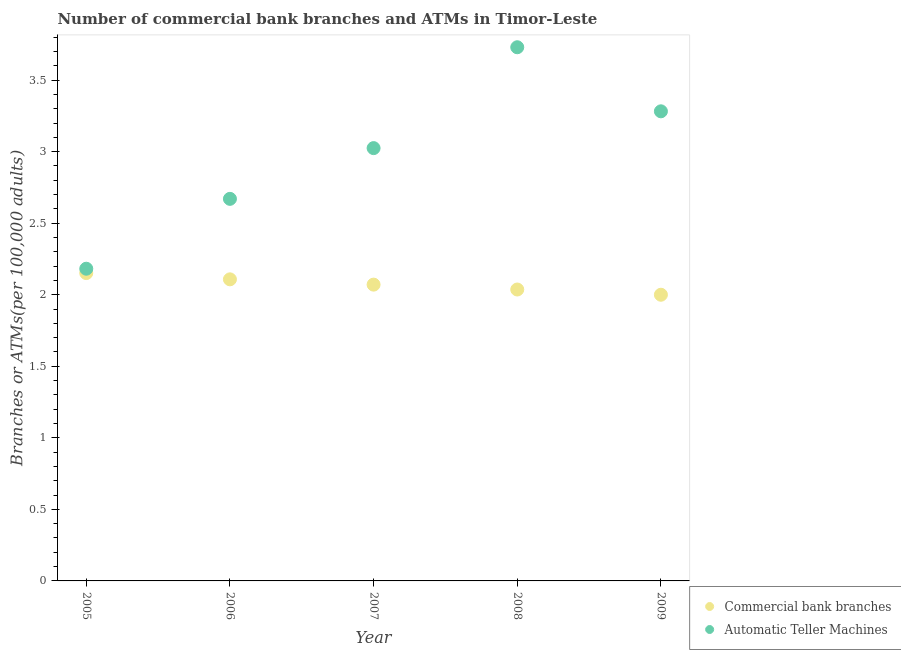How many different coloured dotlines are there?
Provide a succinct answer. 2. What is the number of commercal bank branches in 2005?
Provide a short and direct response. 2.15. Across all years, what is the maximum number of atms?
Your response must be concise. 3.73. Across all years, what is the minimum number of atms?
Keep it short and to the point. 2.18. In which year was the number of atms maximum?
Provide a succinct answer. 2008. What is the total number of atms in the graph?
Keep it short and to the point. 14.89. What is the difference between the number of commercal bank branches in 2007 and that in 2008?
Ensure brevity in your answer.  0.03. What is the difference between the number of commercal bank branches in 2007 and the number of atms in 2009?
Your answer should be compact. -1.21. What is the average number of commercal bank branches per year?
Provide a short and direct response. 2.07. In the year 2006, what is the difference between the number of atms and number of commercal bank branches?
Ensure brevity in your answer.  0.56. In how many years, is the number of atms greater than 0.6?
Offer a terse response. 5. What is the ratio of the number of atms in 2005 to that in 2007?
Your answer should be very brief. 0.72. What is the difference between the highest and the second highest number of atms?
Your response must be concise. 0.45. What is the difference between the highest and the lowest number of atms?
Give a very brief answer. 1.55. In how many years, is the number of commercal bank branches greater than the average number of commercal bank branches taken over all years?
Ensure brevity in your answer.  2. Is the sum of the number of atms in 2006 and 2009 greater than the maximum number of commercal bank branches across all years?
Make the answer very short. Yes. Is the number of atms strictly less than the number of commercal bank branches over the years?
Provide a short and direct response. No. How many dotlines are there?
Provide a short and direct response. 2. What is the difference between two consecutive major ticks on the Y-axis?
Your answer should be compact. 0.5. Where does the legend appear in the graph?
Provide a succinct answer. Bottom right. How many legend labels are there?
Provide a succinct answer. 2. How are the legend labels stacked?
Provide a succinct answer. Vertical. What is the title of the graph?
Offer a very short reply. Number of commercial bank branches and ATMs in Timor-Leste. Does "% of gross capital formation" appear as one of the legend labels in the graph?
Give a very brief answer. No. What is the label or title of the Y-axis?
Ensure brevity in your answer.  Branches or ATMs(per 100,0 adults). What is the Branches or ATMs(per 100,000 adults) in Commercial bank branches in 2005?
Your answer should be very brief. 2.15. What is the Branches or ATMs(per 100,000 adults) of Automatic Teller Machines in 2005?
Ensure brevity in your answer.  2.18. What is the Branches or ATMs(per 100,000 adults) in Commercial bank branches in 2006?
Offer a very short reply. 2.11. What is the Branches or ATMs(per 100,000 adults) in Automatic Teller Machines in 2006?
Your answer should be compact. 2.67. What is the Branches or ATMs(per 100,000 adults) in Commercial bank branches in 2007?
Keep it short and to the point. 2.07. What is the Branches or ATMs(per 100,000 adults) in Automatic Teller Machines in 2007?
Your answer should be compact. 3.02. What is the Branches or ATMs(per 100,000 adults) of Commercial bank branches in 2008?
Provide a succinct answer. 2.04. What is the Branches or ATMs(per 100,000 adults) in Automatic Teller Machines in 2008?
Give a very brief answer. 3.73. What is the Branches or ATMs(per 100,000 adults) in Commercial bank branches in 2009?
Ensure brevity in your answer.  2. What is the Branches or ATMs(per 100,000 adults) in Automatic Teller Machines in 2009?
Your answer should be very brief. 3.28. Across all years, what is the maximum Branches or ATMs(per 100,000 adults) of Commercial bank branches?
Ensure brevity in your answer.  2.15. Across all years, what is the maximum Branches or ATMs(per 100,000 adults) of Automatic Teller Machines?
Ensure brevity in your answer.  3.73. Across all years, what is the minimum Branches or ATMs(per 100,000 adults) of Commercial bank branches?
Provide a short and direct response. 2. Across all years, what is the minimum Branches or ATMs(per 100,000 adults) in Automatic Teller Machines?
Your answer should be compact. 2.18. What is the total Branches or ATMs(per 100,000 adults) in Commercial bank branches in the graph?
Provide a succinct answer. 10.37. What is the total Branches or ATMs(per 100,000 adults) in Automatic Teller Machines in the graph?
Your answer should be very brief. 14.89. What is the difference between the Branches or ATMs(per 100,000 adults) of Commercial bank branches in 2005 and that in 2006?
Give a very brief answer. 0.04. What is the difference between the Branches or ATMs(per 100,000 adults) in Automatic Teller Machines in 2005 and that in 2006?
Give a very brief answer. -0.49. What is the difference between the Branches or ATMs(per 100,000 adults) in Commercial bank branches in 2005 and that in 2007?
Your answer should be very brief. 0.08. What is the difference between the Branches or ATMs(per 100,000 adults) in Automatic Teller Machines in 2005 and that in 2007?
Your answer should be compact. -0.84. What is the difference between the Branches or ATMs(per 100,000 adults) of Commercial bank branches in 2005 and that in 2008?
Offer a very short reply. 0.11. What is the difference between the Branches or ATMs(per 100,000 adults) of Automatic Teller Machines in 2005 and that in 2008?
Make the answer very short. -1.55. What is the difference between the Branches or ATMs(per 100,000 adults) of Commercial bank branches in 2005 and that in 2009?
Offer a terse response. 0.15. What is the difference between the Branches or ATMs(per 100,000 adults) in Automatic Teller Machines in 2005 and that in 2009?
Your answer should be very brief. -1.1. What is the difference between the Branches or ATMs(per 100,000 adults) in Commercial bank branches in 2006 and that in 2007?
Offer a very short reply. 0.04. What is the difference between the Branches or ATMs(per 100,000 adults) in Automatic Teller Machines in 2006 and that in 2007?
Your answer should be compact. -0.35. What is the difference between the Branches or ATMs(per 100,000 adults) of Commercial bank branches in 2006 and that in 2008?
Make the answer very short. 0.07. What is the difference between the Branches or ATMs(per 100,000 adults) in Automatic Teller Machines in 2006 and that in 2008?
Your answer should be very brief. -1.06. What is the difference between the Branches or ATMs(per 100,000 adults) of Commercial bank branches in 2006 and that in 2009?
Provide a short and direct response. 0.11. What is the difference between the Branches or ATMs(per 100,000 adults) in Automatic Teller Machines in 2006 and that in 2009?
Ensure brevity in your answer.  -0.61. What is the difference between the Branches or ATMs(per 100,000 adults) of Commercial bank branches in 2007 and that in 2008?
Your response must be concise. 0.03. What is the difference between the Branches or ATMs(per 100,000 adults) in Automatic Teller Machines in 2007 and that in 2008?
Ensure brevity in your answer.  -0.7. What is the difference between the Branches or ATMs(per 100,000 adults) in Commercial bank branches in 2007 and that in 2009?
Ensure brevity in your answer.  0.07. What is the difference between the Branches or ATMs(per 100,000 adults) in Automatic Teller Machines in 2007 and that in 2009?
Your answer should be very brief. -0.26. What is the difference between the Branches or ATMs(per 100,000 adults) in Commercial bank branches in 2008 and that in 2009?
Offer a terse response. 0.04. What is the difference between the Branches or ATMs(per 100,000 adults) of Automatic Teller Machines in 2008 and that in 2009?
Offer a terse response. 0.45. What is the difference between the Branches or ATMs(per 100,000 adults) of Commercial bank branches in 2005 and the Branches or ATMs(per 100,000 adults) of Automatic Teller Machines in 2006?
Your answer should be compact. -0.52. What is the difference between the Branches or ATMs(per 100,000 adults) in Commercial bank branches in 2005 and the Branches or ATMs(per 100,000 adults) in Automatic Teller Machines in 2007?
Offer a terse response. -0.87. What is the difference between the Branches or ATMs(per 100,000 adults) in Commercial bank branches in 2005 and the Branches or ATMs(per 100,000 adults) in Automatic Teller Machines in 2008?
Keep it short and to the point. -1.58. What is the difference between the Branches or ATMs(per 100,000 adults) of Commercial bank branches in 2005 and the Branches or ATMs(per 100,000 adults) of Automatic Teller Machines in 2009?
Make the answer very short. -1.13. What is the difference between the Branches or ATMs(per 100,000 adults) in Commercial bank branches in 2006 and the Branches or ATMs(per 100,000 adults) in Automatic Teller Machines in 2007?
Your answer should be very brief. -0.92. What is the difference between the Branches or ATMs(per 100,000 adults) in Commercial bank branches in 2006 and the Branches or ATMs(per 100,000 adults) in Automatic Teller Machines in 2008?
Keep it short and to the point. -1.62. What is the difference between the Branches or ATMs(per 100,000 adults) of Commercial bank branches in 2006 and the Branches or ATMs(per 100,000 adults) of Automatic Teller Machines in 2009?
Offer a very short reply. -1.17. What is the difference between the Branches or ATMs(per 100,000 adults) of Commercial bank branches in 2007 and the Branches or ATMs(per 100,000 adults) of Automatic Teller Machines in 2008?
Provide a succinct answer. -1.66. What is the difference between the Branches or ATMs(per 100,000 adults) of Commercial bank branches in 2007 and the Branches or ATMs(per 100,000 adults) of Automatic Teller Machines in 2009?
Your answer should be compact. -1.21. What is the difference between the Branches or ATMs(per 100,000 adults) in Commercial bank branches in 2008 and the Branches or ATMs(per 100,000 adults) in Automatic Teller Machines in 2009?
Your answer should be very brief. -1.25. What is the average Branches or ATMs(per 100,000 adults) in Commercial bank branches per year?
Ensure brevity in your answer.  2.07. What is the average Branches or ATMs(per 100,000 adults) of Automatic Teller Machines per year?
Provide a short and direct response. 2.98. In the year 2005, what is the difference between the Branches or ATMs(per 100,000 adults) in Commercial bank branches and Branches or ATMs(per 100,000 adults) in Automatic Teller Machines?
Make the answer very short. -0.03. In the year 2006, what is the difference between the Branches or ATMs(per 100,000 adults) of Commercial bank branches and Branches or ATMs(per 100,000 adults) of Automatic Teller Machines?
Your response must be concise. -0.56. In the year 2007, what is the difference between the Branches or ATMs(per 100,000 adults) of Commercial bank branches and Branches or ATMs(per 100,000 adults) of Automatic Teller Machines?
Your answer should be compact. -0.95. In the year 2008, what is the difference between the Branches or ATMs(per 100,000 adults) of Commercial bank branches and Branches or ATMs(per 100,000 adults) of Automatic Teller Machines?
Provide a succinct answer. -1.69. In the year 2009, what is the difference between the Branches or ATMs(per 100,000 adults) of Commercial bank branches and Branches or ATMs(per 100,000 adults) of Automatic Teller Machines?
Keep it short and to the point. -1.28. What is the ratio of the Branches or ATMs(per 100,000 adults) of Commercial bank branches in 2005 to that in 2006?
Ensure brevity in your answer.  1.02. What is the ratio of the Branches or ATMs(per 100,000 adults) of Automatic Teller Machines in 2005 to that in 2006?
Make the answer very short. 0.82. What is the ratio of the Branches or ATMs(per 100,000 adults) in Commercial bank branches in 2005 to that in 2007?
Offer a terse response. 1.04. What is the ratio of the Branches or ATMs(per 100,000 adults) of Automatic Teller Machines in 2005 to that in 2007?
Provide a succinct answer. 0.72. What is the ratio of the Branches or ATMs(per 100,000 adults) in Commercial bank branches in 2005 to that in 2008?
Give a very brief answer. 1.06. What is the ratio of the Branches or ATMs(per 100,000 adults) in Automatic Teller Machines in 2005 to that in 2008?
Give a very brief answer. 0.58. What is the ratio of the Branches or ATMs(per 100,000 adults) in Commercial bank branches in 2005 to that in 2009?
Provide a succinct answer. 1.08. What is the ratio of the Branches or ATMs(per 100,000 adults) in Automatic Teller Machines in 2005 to that in 2009?
Provide a short and direct response. 0.66. What is the ratio of the Branches or ATMs(per 100,000 adults) of Commercial bank branches in 2006 to that in 2007?
Offer a terse response. 1.02. What is the ratio of the Branches or ATMs(per 100,000 adults) in Automatic Teller Machines in 2006 to that in 2007?
Offer a very short reply. 0.88. What is the ratio of the Branches or ATMs(per 100,000 adults) in Commercial bank branches in 2006 to that in 2008?
Your answer should be compact. 1.03. What is the ratio of the Branches or ATMs(per 100,000 adults) in Automatic Teller Machines in 2006 to that in 2008?
Your answer should be compact. 0.72. What is the ratio of the Branches or ATMs(per 100,000 adults) of Commercial bank branches in 2006 to that in 2009?
Provide a short and direct response. 1.05. What is the ratio of the Branches or ATMs(per 100,000 adults) in Automatic Teller Machines in 2006 to that in 2009?
Your answer should be very brief. 0.81. What is the ratio of the Branches or ATMs(per 100,000 adults) in Commercial bank branches in 2007 to that in 2008?
Your answer should be compact. 1.02. What is the ratio of the Branches or ATMs(per 100,000 adults) in Automatic Teller Machines in 2007 to that in 2008?
Provide a short and direct response. 0.81. What is the ratio of the Branches or ATMs(per 100,000 adults) in Commercial bank branches in 2007 to that in 2009?
Ensure brevity in your answer.  1.04. What is the ratio of the Branches or ATMs(per 100,000 adults) of Automatic Teller Machines in 2007 to that in 2009?
Your answer should be very brief. 0.92. What is the ratio of the Branches or ATMs(per 100,000 adults) of Commercial bank branches in 2008 to that in 2009?
Offer a very short reply. 1.02. What is the ratio of the Branches or ATMs(per 100,000 adults) in Automatic Teller Machines in 2008 to that in 2009?
Offer a very short reply. 1.14. What is the difference between the highest and the second highest Branches or ATMs(per 100,000 adults) of Commercial bank branches?
Offer a terse response. 0.04. What is the difference between the highest and the second highest Branches or ATMs(per 100,000 adults) in Automatic Teller Machines?
Your response must be concise. 0.45. What is the difference between the highest and the lowest Branches or ATMs(per 100,000 adults) of Commercial bank branches?
Ensure brevity in your answer.  0.15. What is the difference between the highest and the lowest Branches or ATMs(per 100,000 adults) of Automatic Teller Machines?
Offer a terse response. 1.55. 